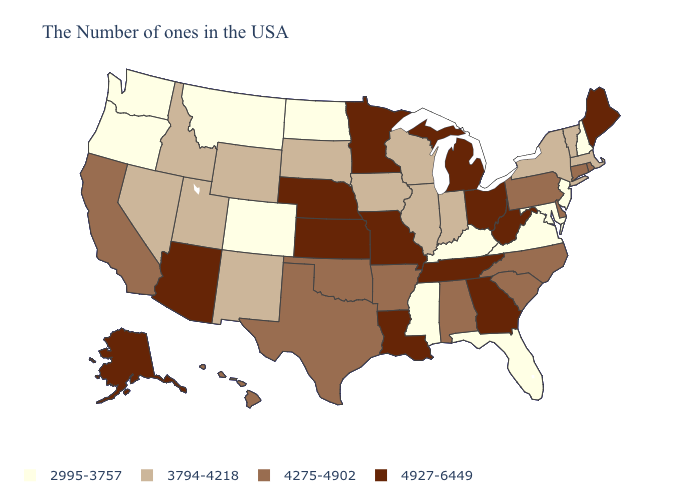Name the states that have a value in the range 3794-4218?
Concise answer only. Massachusetts, Vermont, New York, Indiana, Wisconsin, Illinois, Iowa, South Dakota, Wyoming, New Mexico, Utah, Idaho, Nevada. What is the value of Delaware?
Keep it brief. 4275-4902. What is the lowest value in the South?
Be succinct. 2995-3757. What is the value of Maine?
Be succinct. 4927-6449. What is the value of Arkansas?
Quick response, please. 4275-4902. What is the value of Tennessee?
Keep it brief. 4927-6449. Does Colorado have the lowest value in the West?
Short answer required. Yes. Name the states that have a value in the range 2995-3757?
Answer briefly. New Hampshire, New Jersey, Maryland, Virginia, Florida, Kentucky, Mississippi, North Dakota, Colorado, Montana, Washington, Oregon. Does Indiana have the same value as New Hampshire?
Concise answer only. No. Which states have the highest value in the USA?
Keep it brief. Maine, West Virginia, Ohio, Georgia, Michigan, Tennessee, Louisiana, Missouri, Minnesota, Kansas, Nebraska, Arizona, Alaska. What is the value of Alaska?
Keep it brief. 4927-6449. What is the value of Connecticut?
Be succinct. 4275-4902. What is the lowest value in the USA?
Quick response, please. 2995-3757. Among the states that border Nevada , which have the highest value?
Concise answer only. Arizona. Does New Jersey have the highest value in the USA?
Write a very short answer. No. 